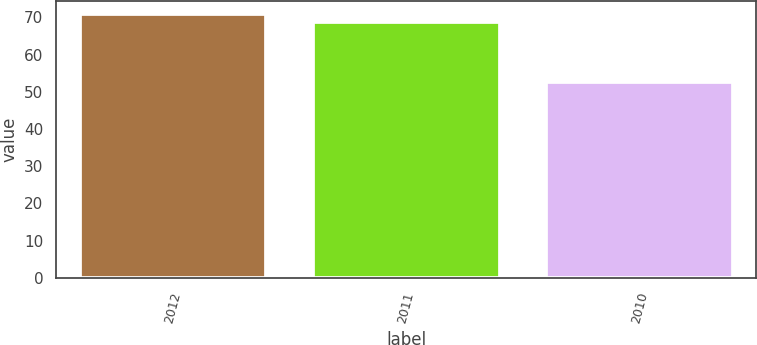Convert chart. <chart><loc_0><loc_0><loc_500><loc_500><bar_chart><fcel>2012<fcel>2011<fcel>2010<nl><fcel>71<fcel>68.9<fcel>52.6<nl></chart> 